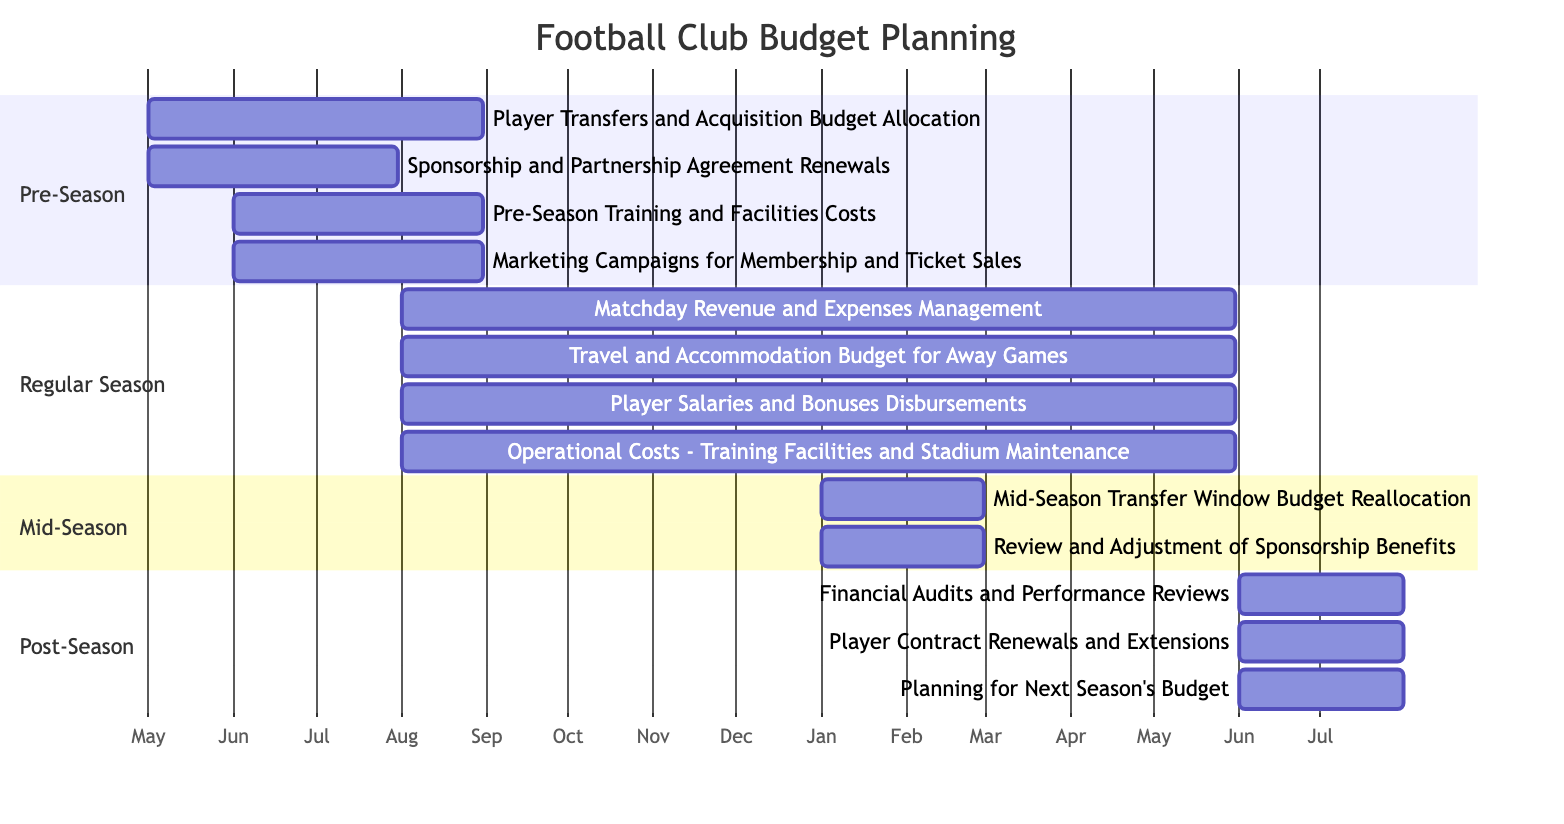What is the duration of the Pre-Season phase? The Pre-Season phase starts in May and ends in August. Counting the months from May to August gives us a total of 4 months.
Answer: 4 months Which task spans the entire Regular Season? The Regular Season runs from August to May. The task "Matchday Revenue and Expenses Management" starts in August and also ends in May, indicating it encompasses the entire Regular Season.
Answer: Matchday Revenue and Expenses Management How many tasks are in the Post-Season phase? The Post-Season phase lists three distinct tasks: "Financial Audits and Performance Reviews," "Player Contract Renewals and Extensions," and "Planning for Next Season's Budget." The total count of these tasks is three.
Answer: 3 During which month does the Mid-Season Transfer Window Budget Reallocation occur? The task "Mid-Season Transfer Window Budget Reallocation" starts in January and ends in February. Since it begins in January, this month is when it occurs.
Answer: January Which phase has the highest number of tasks? Examining the tasks across each phase, the Regular Season has four tasks, while the Pre-Season has four, Mid-Season has two, and Post-Season has three. Therefore, both Pre-Season and Regular Season have the same highest task count of four.
Answer: Pre-Season and Regular Season What is the end date for Player Transfers and Acquisition Budget Allocation? The task "Player Transfers and Acquisition Budget Allocation" starts in May and ends in August. The end date is clearly stated in the diagram, which makes it obvious.
Answer: August What are the two tasks that overlap in the Post-Season? In the Post-Season phase, "Financial Audits and Performance Reviews," "Player Contract Renewals and Extensions," and "Planning for Next Season's Budget" all start in June and end in July. Their overlapping duration indicates these two tasks share the same timeline.
Answer: Financial Audits and Performance Reviews, Player Contract Renewals and Extensions What months encompass the Regular Season? The Regular Season tasks start in August and end in May the following year. Consequently, the months included in this time frame are August through May.
Answer: August to May 